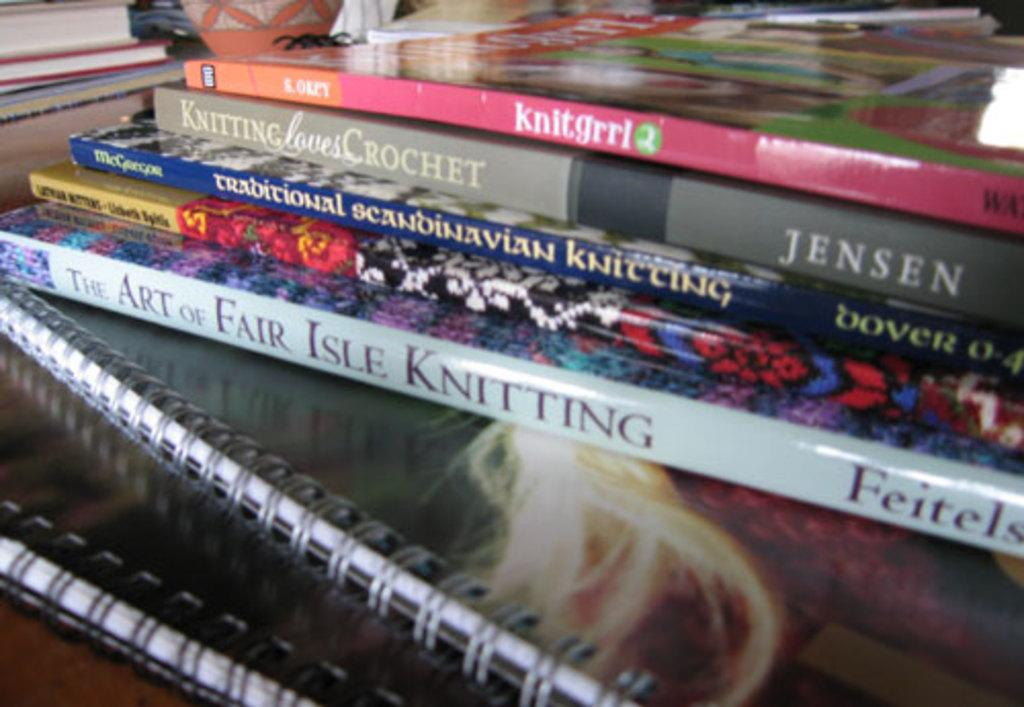<image>
Describe the image concisely. A book called Knit Grrl sits atop some other books about knitting. 